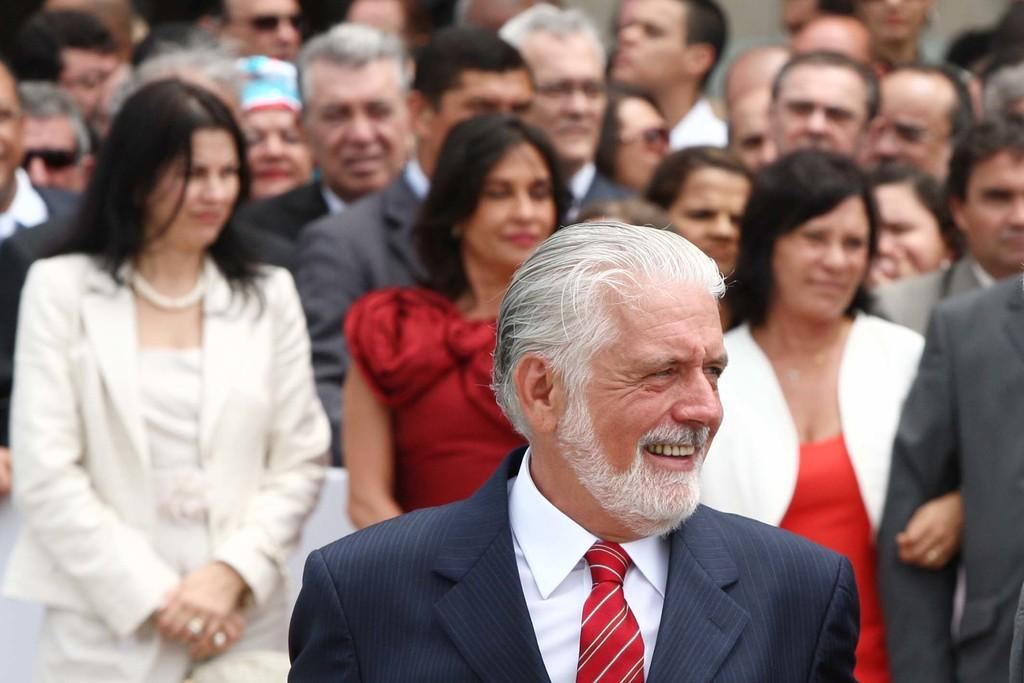How many people are in the image? There are people in the image, but the exact number is not specified. What type of clothing are some of the people wearing? Some of the people are wearing coats. Can you describe the headwear of one of the individuals? One person is wearing a cap. What type of organization is depicted in the image? There is no organization depicted in the image; it features people wearing coats and a cap. Can you tell me how many tigers are present in the image? There are no tigers present in the image. 